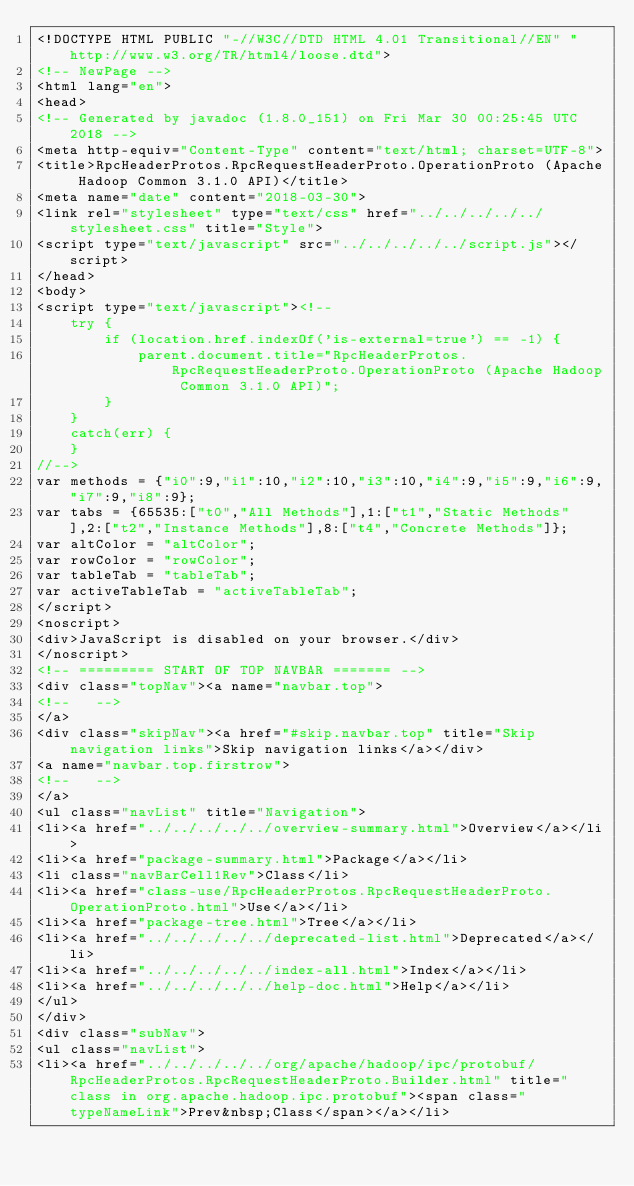<code> <loc_0><loc_0><loc_500><loc_500><_HTML_><!DOCTYPE HTML PUBLIC "-//W3C//DTD HTML 4.01 Transitional//EN" "http://www.w3.org/TR/html4/loose.dtd">
<!-- NewPage -->
<html lang="en">
<head>
<!-- Generated by javadoc (1.8.0_151) on Fri Mar 30 00:25:45 UTC 2018 -->
<meta http-equiv="Content-Type" content="text/html; charset=UTF-8">
<title>RpcHeaderProtos.RpcRequestHeaderProto.OperationProto (Apache Hadoop Common 3.1.0 API)</title>
<meta name="date" content="2018-03-30">
<link rel="stylesheet" type="text/css" href="../../../../../stylesheet.css" title="Style">
<script type="text/javascript" src="../../../../../script.js"></script>
</head>
<body>
<script type="text/javascript"><!--
    try {
        if (location.href.indexOf('is-external=true') == -1) {
            parent.document.title="RpcHeaderProtos.RpcRequestHeaderProto.OperationProto (Apache Hadoop Common 3.1.0 API)";
        }
    }
    catch(err) {
    }
//-->
var methods = {"i0":9,"i1":10,"i2":10,"i3":10,"i4":9,"i5":9,"i6":9,"i7":9,"i8":9};
var tabs = {65535:["t0","All Methods"],1:["t1","Static Methods"],2:["t2","Instance Methods"],8:["t4","Concrete Methods"]};
var altColor = "altColor";
var rowColor = "rowColor";
var tableTab = "tableTab";
var activeTableTab = "activeTableTab";
</script>
<noscript>
<div>JavaScript is disabled on your browser.</div>
</noscript>
<!-- ========= START OF TOP NAVBAR ======= -->
<div class="topNav"><a name="navbar.top">
<!--   -->
</a>
<div class="skipNav"><a href="#skip.navbar.top" title="Skip navigation links">Skip navigation links</a></div>
<a name="navbar.top.firstrow">
<!--   -->
</a>
<ul class="navList" title="Navigation">
<li><a href="../../../../../overview-summary.html">Overview</a></li>
<li><a href="package-summary.html">Package</a></li>
<li class="navBarCell1Rev">Class</li>
<li><a href="class-use/RpcHeaderProtos.RpcRequestHeaderProto.OperationProto.html">Use</a></li>
<li><a href="package-tree.html">Tree</a></li>
<li><a href="../../../../../deprecated-list.html">Deprecated</a></li>
<li><a href="../../../../../index-all.html">Index</a></li>
<li><a href="../../../../../help-doc.html">Help</a></li>
</ul>
</div>
<div class="subNav">
<ul class="navList">
<li><a href="../../../../../org/apache/hadoop/ipc/protobuf/RpcHeaderProtos.RpcRequestHeaderProto.Builder.html" title="class in org.apache.hadoop.ipc.protobuf"><span class="typeNameLink">Prev&nbsp;Class</span></a></li></code> 